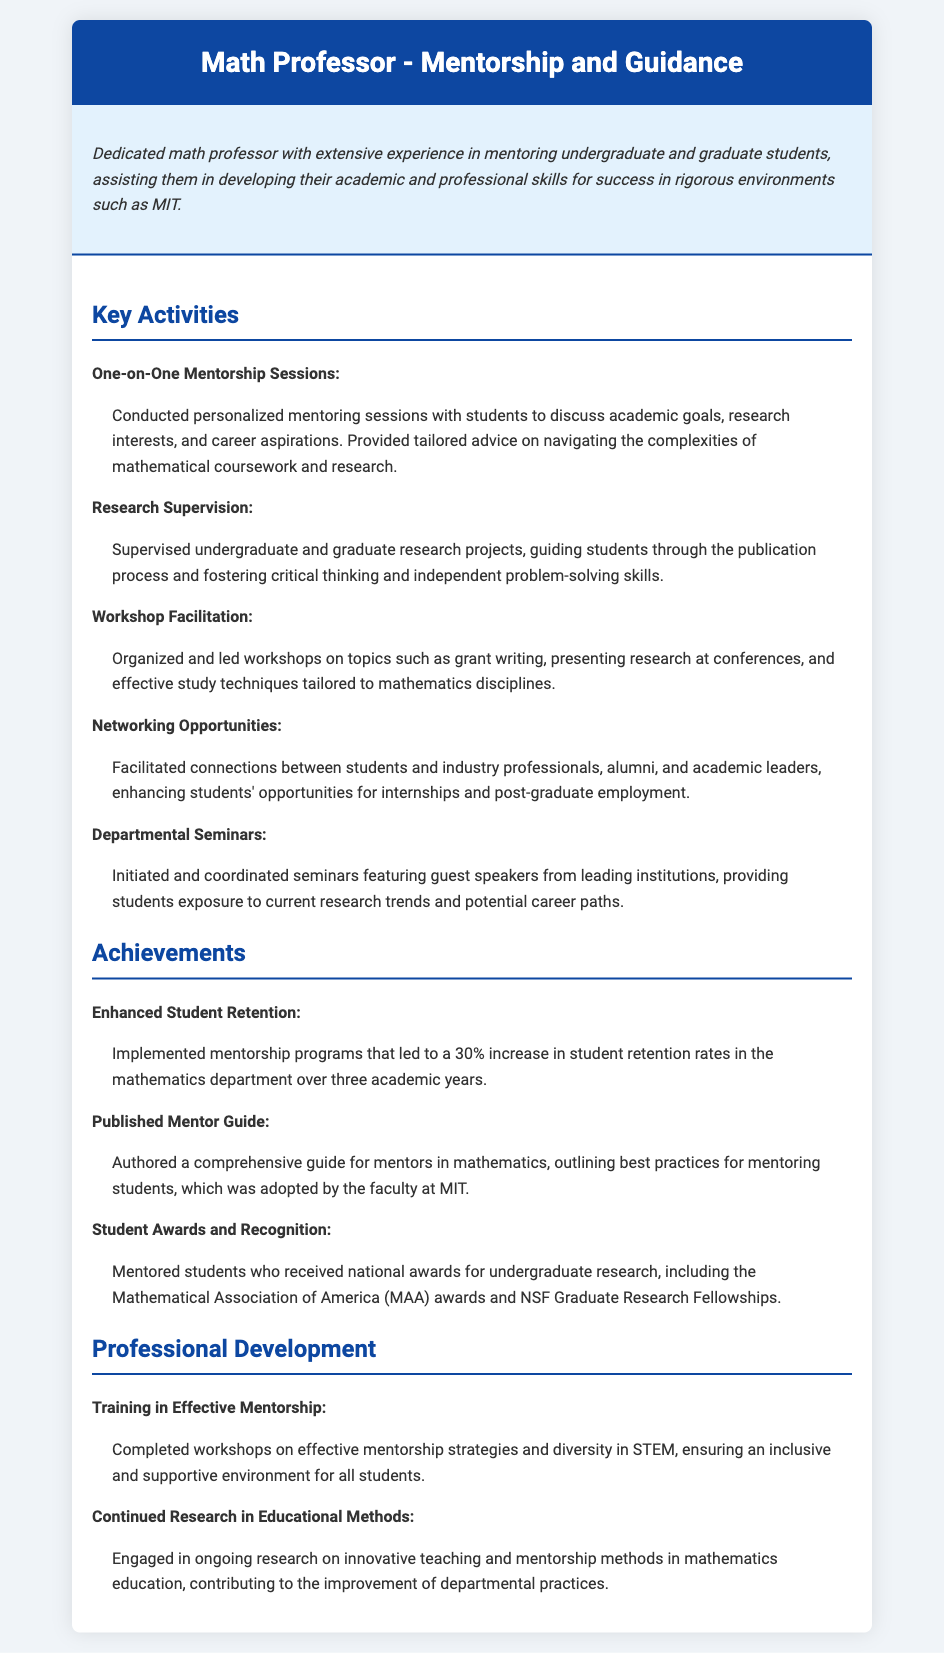what is the title of this document? The title is indicated prominently in the header of the document.
Answer: Math Professor - Mentorship and Guidance how many key activities are listed in the document? The number of key activities is counted under the "Key Activities" section.
Answer: Five what percentage increase in student retention rates is mentioned? The percentage increase is specified as part of an achievement related to student retention.
Answer: 30% who authored the mentor guide mentioned in the achievements? The author of the mentor guide is the individual represented in the document.
Answer: Math Professor what types of awards did mentored students receive? The document specifies the types of awards received by students mentored by the professor.
Answer: National awards what topic was covered in the workshop facilitation activity? The specific topic of the workshops is listed under the "Key Activities" section.
Answer: Grant writing which organization recognized students mentored by the professor? The organization is mentioned in relation to student awards in the achievements section.
Answer: Mathematical Association of America what type of training did the professor complete for professional development? The type of training is specified in the "Professional Development" section.
Answer: Effective mentorship how did the professor enhance networking opportunities for students? The method of enhancing networking opportunities is described in the "Key Activities" section.
Answer: Facilitated connections 